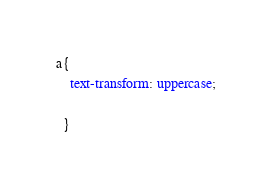<code> <loc_0><loc_0><loc_500><loc_500><_CSS_>a{
    text-transform: uppercase;
    
  }</code> 